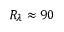<formula> <loc_0><loc_0><loc_500><loc_500>R _ { \lambda } \approx 9 0</formula> 